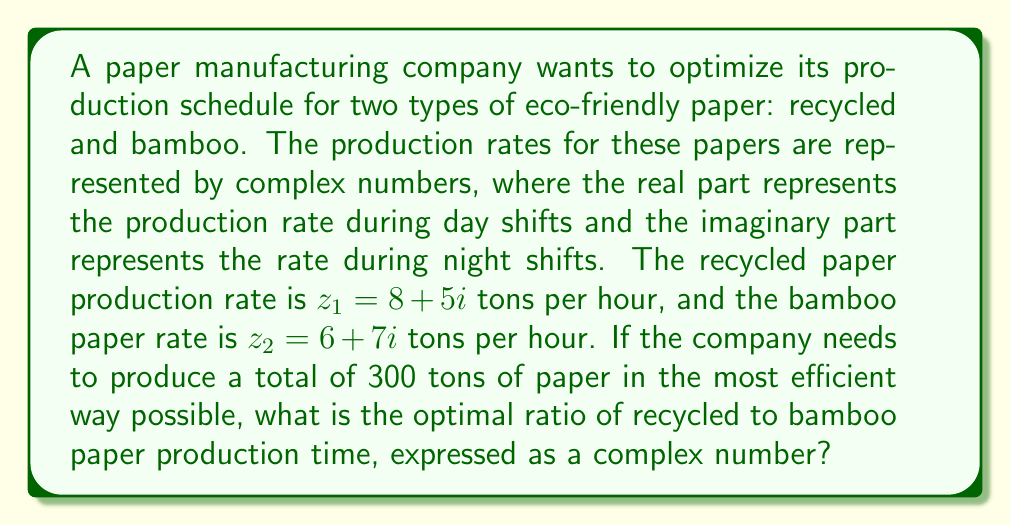Solve this math problem. Let's approach this step-by-step:

1) First, we need to find the magnitude of each complex number, which represents the total production rate for each type of paper:

   For recycled paper: $|z_1| = \sqrt{8^2 + 5^2} = \sqrt{89}$
   For bamboo paper: $|z_2| = \sqrt{6^2 + 7^2} = \sqrt{85}$

2) The optimal production ratio will be inversely proportional to these magnitudes. Let's call the ratio $w = a + bi$, where $a$ represents the proportion of time for recycled paper and $b$ for bamboo paper.

3) We can set up the equation:

   $\frac{a}{b} = \frac{|z_2|}{|z_1|} = \frac{\sqrt{85}}{\sqrt{89}}$

4) We also know that $a + b = 1$, as the total proportion of time must be 1.

5) Solving these equations:

   $a = \frac{\sqrt{85}}{\sqrt{85} + \sqrt{89}}$ and $b = \frac{\sqrt{89}}{\sqrt{85} + \sqrt{89}}$

6) To express this as a complex number, we need to rationalize the denominator:

   $w = \frac{\sqrt{85}}{\sqrt{85} + \sqrt{89}} + \frac{\sqrt{89}}{\sqrt{85} + \sqrt{89}}i$

7) Multiplying both numerator and denominator by $\sqrt{85} - \sqrt{89}$:

   $w = \frac{85 - \sqrt{85}\sqrt{89}}{85 - 89} + \frac{\sqrt{89}\sqrt{85} - 89}{85 - 89}i$

8) Simplifying:

   $w = \frac{\sqrt{85}\sqrt{89} - 85}{4} + \frac{89 - \sqrt{85}\sqrt{89}}{4}i$

This complex number $w$ represents the optimal ratio of production time for recycled paper (real part) to bamboo paper (imaginary part).
Answer: $w = \frac{\sqrt{85}\sqrt{89} - 85}{4} + \frac{89 - \sqrt{85}\sqrt{89}}{4}i$ 